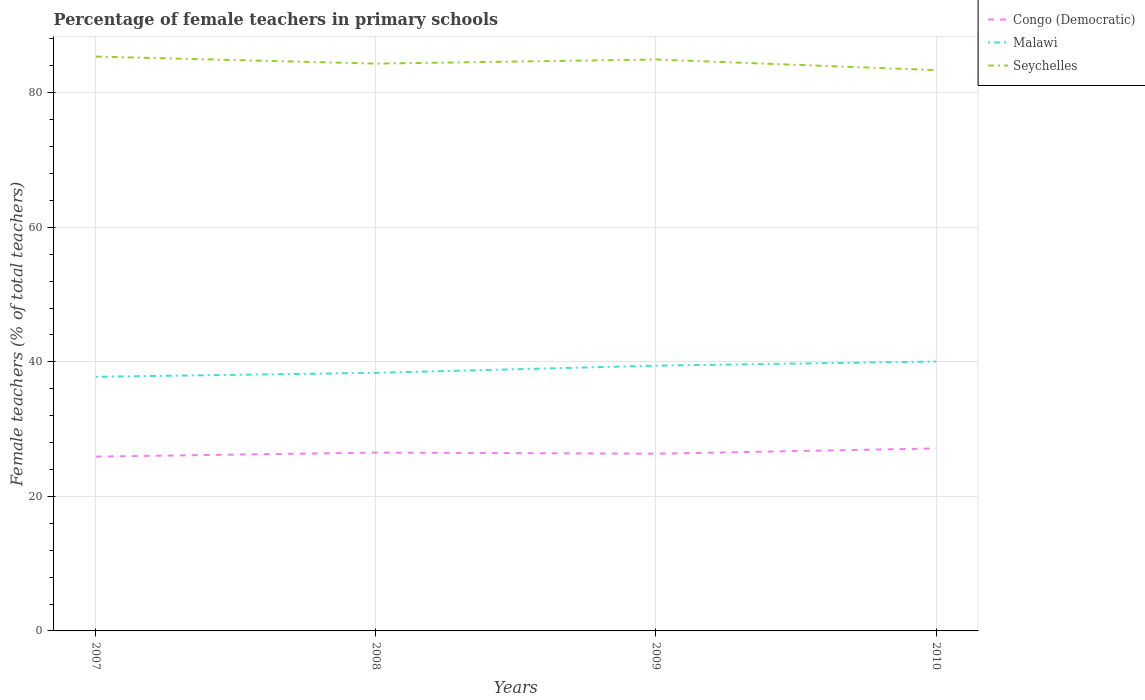Does the line corresponding to Seychelles intersect with the line corresponding to Malawi?
Your response must be concise. No. Across all years, what is the maximum percentage of female teachers in Seychelles?
Your answer should be compact. 83.36. What is the total percentage of female teachers in Congo (Democratic) in the graph?
Your answer should be compact. -0.78. What is the difference between the highest and the second highest percentage of female teachers in Malawi?
Provide a short and direct response. 2.27. Is the percentage of female teachers in Malawi strictly greater than the percentage of female teachers in Congo (Democratic) over the years?
Provide a short and direct response. No. How many lines are there?
Give a very brief answer. 3. Does the graph contain any zero values?
Provide a short and direct response. No. How many legend labels are there?
Your response must be concise. 3. How are the legend labels stacked?
Offer a very short reply. Vertical. What is the title of the graph?
Provide a short and direct response. Percentage of female teachers in primary schools. Does "Turkey" appear as one of the legend labels in the graph?
Your answer should be very brief. No. What is the label or title of the Y-axis?
Give a very brief answer. Female teachers (% of total teachers). What is the Female teachers (% of total teachers) of Congo (Democratic) in 2007?
Offer a very short reply. 25.91. What is the Female teachers (% of total teachers) in Malawi in 2007?
Make the answer very short. 37.77. What is the Female teachers (% of total teachers) in Seychelles in 2007?
Make the answer very short. 85.37. What is the Female teachers (% of total teachers) of Congo (Democratic) in 2008?
Provide a succinct answer. 26.51. What is the Female teachers (% of total teachers) of Malawi in 2008?
Offer a very short reply. 38.36. What is the Female teachers (% of total teachers) in Seychelles in 2008?
Offer a very short reply. 84.33. What is the Female teachers (% of total teachers) in Congo (Democratic) in 2009?
Make the answer very short. 26.34. What is the Female teachers (% of total teachers) of Malawi in 2009?
Offer a terse response. 39.43. What is the Female teachers (% of total teachers) of Seychelles in 2009?
Your answer should be compact. 84.94. What is the Female teachers (% of total teachers) in Congo (Democratic) in 2010?
Make the answer very short. 27.13. What is the Female teachers (% of total teachers) of Malawi in 2010?
Provide a succinct answer. 40.04. What is the Female teachers (% of total teachers) in Seychelles in 2010?
Offer a terse response. 83.36. Across all years, what is the maximum Female teachers (% of total teachers) of Congo (Democratic)?
Your answer should be compact. 27.13. Across all years, what is the maximum Female teachers (% of total teachers) of Malawi?
Provide a succinct answer. 40.04. Across all years, what is the maximum Female teachers (% of total teachers) of Seychelles?
Give a very brief answer. 85.37. Across all years, what is the minimum Female teachers (% of total teachers) of Congo (Democratic)?
Offer a terse response. 25.91. Across all years, what is the minimum Female teachers (% of total teachers) of Malawi?
Offer a terse response. 37.77. Across all years, what is the minimum Female teachers (% of total teachers) of Seychelles?
Offer a very short reply. 83.36. What is the total Female teachers (% of total teachers) of Congo (Democratic) in the graph?
Make the answer very short. 105.89. What is the total Female teachers (% of total teachers) of Malawi in the graph?
Your answer should be very brief. 155.61. What is the total Female teachers (% of total teachers) of Seychelles in the graph?
Make the answer very short. 337.99. What is the difference between the Female teachers (% of total teachers) in Congo (Democratic) in 2007 and that in 2008?
Your answer should be very brief. -0.6. What is the difference between the Female teachers (% of total teachers) in Malawi in 2007 and that in 2008?
Your answer should be compact. -0.59. What is the difference between the Female teachers (% of total teachers) in Seychelles in 2007 and that in 2008?
Give a very brief answer. 1.04. What is the difference between the Female teachers (% of total teachers) in Congo (Democratic) in 2007 and that in 2009?
Your answer should be compact. -0.44. What is the difference between the Female teachers (% of total teachers) in Malawi in 2007 and that in 2009?
Ensure brevity in your answer.  -1.66. What is the difference between the Female teachers (% of total teachers) of Seychelles in 2007 and that in 2009?
Your answer should be compact. 0.44. What is the difference between the Female teachers (% of total teachers) of Congo (Democratic) in 2007 and that in 2010?
Provide a succinct answer. -1.22. What is the difference between the Female teachers (% of total teachers) of Malawi in 2007 and that in 2010?
Offer a very short reply. -2.27. What is the difference between the Female teachers (% of total teachers) in Seychelles in 2007 and that in 2010?
Provide a short and direct response. 2.02. What is the difference between the Female teachers (% of total teachers) in Congo (Democratic) in 2008 and that in 2009?
Your answer should be compact. 0.17. What is the difference between the Female teachers (% of total teachers) in Malawi in 2008 and that in 2009?
Keep it short and to the point. -1.07. What is the difference between the Female teachers (% of total teachers) of Seychelles in 2008 and that in 2009?
Offer a terse response. -0.61. What is the difference between the Female teachers (% of total teachers) in Congo (Democratic) in 2008 and that in 2010?
Provide a succinct answer. -0.62. What is the difference between the Female teachers (% of total teachers) of Malawi in 2008 and that in 2010?
Keep it short and to the point. -1.68. What is the difference between the Female teachers (% of total teachers) of Seychelles in 2008 and that in 2010?
Provide a succinct answer. 0.97. What is the difference between the Female teachers (% of total teachers) in Congo (Democratic) in 2009 and that in 2010?
Your answer should be very brief. -0.78. What is the difference between the Female teachers (% of total teachers) in Malawi in 2009 and that in 2010?
Provide a succinct answer. -0.61. What is the difference between the Female teachers (% of total teachers) in Seychelles in 2009 and that in 2010?
Provide a short and direct response. 1.58. What is the difference between the Female teachers (% of total teachers) of Congo (Democratic) in 2007 and the Female teachers (% of total teachers) of Malawi in 2008?
Offer a very short reply. -12.45. What is the difference between the Female teachers (% of total teachers) of Congo (Democratic) in 2007 and the Female teachers (% of total teachers) of Seychelles in 2008?
Your answer should be very brief. -58.42. What is the difference between the Female teachers (% of total teachers) of Malawi in 2007 and the Female teachers (% of total teachers) of Seychelles in 2008?
Provide a short and direct response. -46.56. What is the difference between the Female teachers (% of total teachers) in Congo (Democratic) in 2007 and the Female teachers (% of total teachers) in Malawi in 2009?
Provide a succinct answer. -13.52. What is the difference between the Female teachers (% of total teachers) of Congo (Democratic) in 2007 and the Female teachers (% of total teachers) of Seychelles in 2009?
Your answer should be very brief. -59.03. What is the difference between the Female teachers (% of total teachers) in Malawi in 2007 and the Female teachers (% of total teachers) in Seychelles in 2009?
Make the answer very short. -47.16. What is the difference between the Female teachers (% of total teachers) of Congo (Democratic) in 2007 and the Female teachers (% of total teachers) of Malawi in 2010?
Ensure brevity in your answer.  -14.13. What is the difference between the Female teachers (% of total teachers) of Congo (Democratic) in 2007 and the Female teachers (% of total teachers) of Seychelles in 2010?
Keep it short and to the point. -57.45. What is the difference between the Female teachers (% of total teachers) in Malawi in 2007 and the Female teachers (% of total teachers) in Seychelles in 2010?
Make the answer very short. -45.58. What is the difference between the Female teachers (% of total teachers) in Congo (Democratic) in 2008 and the Female teachers (% of total teachers) in Malawi in 2009?
Offer a very short reply. -12.92. What is the difference between the Female teachers (% of total teachers) in Congo (Democratic) in 2008 and the Female teachers (% of total teachers) in Seychelles in 2009?
Provide a succinct answer. -58.43. What is the difference between the Female teachers (% of total teachers) of Malawi in 2008 and the Female teachers (% of total teachers) of Seychelles in 2009?
Provide a succinct answer. -46.57. What is the difference between the Female teachers (% of total teachers) of Congo (Democratic) in 2008 and the Female teachers (% of total teachers) of Malawi in 2010?
Your answer should be compact. -13.53. What is the difference between the Female teachers (% of total teachers) in Congo (Democratic) in 2008 and the Female teachers (% of total teachers) in Seychelles in 2010?
Provide a short and direct response. -56.85. What is the difference between the Female teachers (% of total teachers) of Malawi in 2008 and the Female teachers (% of total teachers) of Seychelles in 2010?
Provide a short and direct response. -44.99. What is the difference between the Female teachers (% of total teachers) in Congo (Democratic) in 2009 and the Female teachers (% of total teachers) in Malawi in 2010?
Provide a succinct answer. -13.7. What is the difference between the Female teachers (% of total teachers) in Congo (Democratic) in 2009 and the Female teachers (% of total teachers) in Seychelles in 2010?
Keep it short and to the point. -57.01. What is the difference between the Female teachers (% of total teachers) in Malawi in 2009 and the Female teachers (% of total teachers) in Seychelles in 2010?
Your answer should be very brief. -43.93. What is the average Female teachers (% of total teachers) in Congo (Democratic) per year?
Your response must be concise. 26.47. What is the average Female teachers (% of total teachers) in Malawi per year?
Give a very brief answer. 38.9. What is the average Female teachers (% of total teachers) of Seychelles per year?
Your response must be concise. 84.5. In the year 2007, what is the difference between the Female teachers (% of total teachers) in Congo (Democratic) and Female teachers (% of total teachers) in Malawi?
Offer a very short reply. -11.86. In the year 2007, what is the difference between the Female teachers (% of total teachers) of Congo (Democratic) and Female teachers (% of total teachers) of Seychelles?
Your response must be concise. -59.46. In the year 2007, what is the difference between the Female teachers (% of total teachers) in Malawi and Female teachers (% of total teachers) in Seychelles?
Offer a very short reply. -47.6. In the year 2008, what is the difference between the Female teachers (% of total teachers) of Congo (Democratic) and Female teachers (% of total teachers) of Malawi?
Ensure brevity in your answer.  -11.85. In the year 2008, what is the difference between the Female teachers (% of total teachers) in Congo (Democratic) and Female teachers (% of total teachers) in Seychelles?
Provide a short and direct response. -57.82. In the year 2008, what is the difference between the Female teachers (% of total teachers) in Malawi and Female teachers (% of total teachers) in Seychelles?
Offer a terse response. -45.97. In the year 2009, what is the difference between the Female teachers (% of total teachers) of Congo (Democratic) and Female teachers (% of total teachers) of Malawi?
Your response must be concise. -13.09. In the year 2009, what is the difference between the Female teachers (% of total teachers) of Congo (Democratic) and Female teachers (% of total teachers) of Seychelles?
Give a very brief answer. -58.59. In the year 2009, what is the difference between the Female teachers (% of total teachers) of Malawi and Female teachers (% of total teachers) of Seychelles?
Your response must be concise. -45.51. In the year 2010, what is the difference between the Female teachers (% of total teachers) of Congo (Democratic) and Female teachers (% of total teachers) of Malawi?
Make the answer very short. -12.91. In the year 2010, what is the difference between the Female teachers (% of total teachers) in Congo (Democratic) and Female teachers (% of total teachers) in Seychelles?
Give a very brief answer. -56.23. In the year 2010, what is the difference between the Female teachers (% of total teachers) of Malawi and Female teachers (% of total teachers) of Seychelles?
Provide a succinct answer. -43.32. What is the ratio of the Female teachers (% of total teachers) in Congo (Democratic) in 2007 to that in 2008?
Offer a very short reply. 0.98. What is the ratio of the Female teachers (% of total teachers) in Malawi in 2007 to that in 2008?
Your answer should be compact. 0.98. What is the ratio of the Female teachers (% of total teachers) in Seychelles in 2007 to that in 2008?
Your response must be concise. 1.01. What is the ratio of the Female teachers (% of total teachers) of Congo (Democratic) in 2007 to that in 2009?
Give a very brief answer. 0.98. What is the ratio of the Female teachers (% of total teachers) in Malawi in 2007 to that in 2009?
Your answer should be very brief. 0.96. What is the ratio of the Female teachers (% of total teachers) of Congo (Democratic) in 2007 to that in 2010?
Give a very brief answer. 0.96. What is the ratio of the Female teachers (% of total teachers) of Malawi in 2007 to that in 2010?
Your response must be concise. 0.94. What is the ratio of the Female teachers (% of total teachers) of Seychelles in 2007 to that in 2010?
Your response must be concise. 1.02. What is the ratio of the Female teachers (% of total teachers) of Malawi in 2008 to that in 2009?
Your response must be concise. 0.97. What is the ratio of the Female teachers (% of total teachers) in Congo (Democratic) in 2008 to that in 2010?
Provide a succinct answer. 0.98. What is the ratio of the Female teachers (% of total teachers) of Malawi in 2008 to that in 2010?
Provide a succinct answer. 0.96. What is the ratio of the Female teachers (% of total teachers) in Seychelles in 2008 to that in 2010?
Offer a very short reply. 1.01. What is the ratio of the Female teachers (% of total teachers) in Congo (Democratic) in 2009 to that in 2010?
Offer a very short reply. 0.97. What is the ratio of the Female teachers (% of total teachers) of Malawi in 2009 to that in 2010?
Keep it short and to the point. 0.98. What is the ratio of the Female teachers (% of total teachers) of Seychelles in 2009 to that in 2010?
Provide a short and direct response. 1.02. What is the difference between the highest and the second highest Female teachers (% of total teachers) of Congo (Democratic)?
Your answer should be compact. 0.62. What is the difference between the highest and the second highest Female teachers (% of total teachers) in Malawi?
Offer a terse response. 0.61. What is the difference between the highest and the second highest Female teachers (% of total teachers) of Seychelles?
Ensure brevity in your answer.  0.44. What is the difference between the highest and the lowest Female teachers (% of total teachers) of Congo (Democratic)?
Provide a short and direct response. 1.22. What is the difference between the highest and the lowest Female teachers (% of total teachers) in Malawi?
Give a very brief answer. 2.27. What is the difference between the highest and the lowest Female teachers (% of total teachers) of Seychelles?
Make the answer very short. 2.02. 